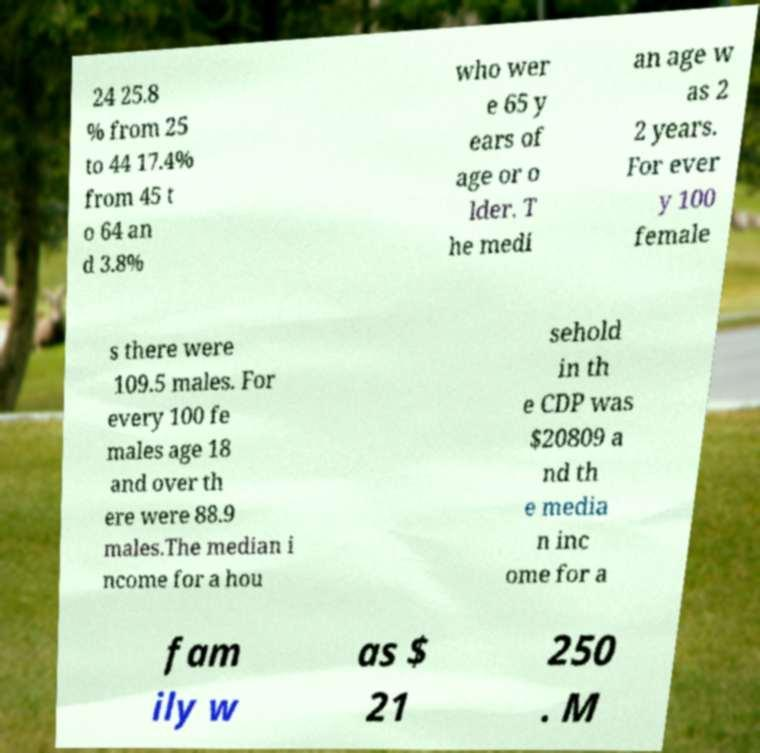Please identify and transcribe the text found in this image. 24 25.8 % from 25 to 44 17.4% from 45 t o 64 an d 3.8% who wer e 65 y ears of age or o lder. T he medi an age w as 2 2 years. For ever y 100 female s there were 109.5 males. For every 100 fe males age 18 and over th ere were 88.9 males.The median i ncome for a hou sehold in th e CDP was $20809 a nd th e media n inc ome for a fam ily w as $ 21 250 . M 